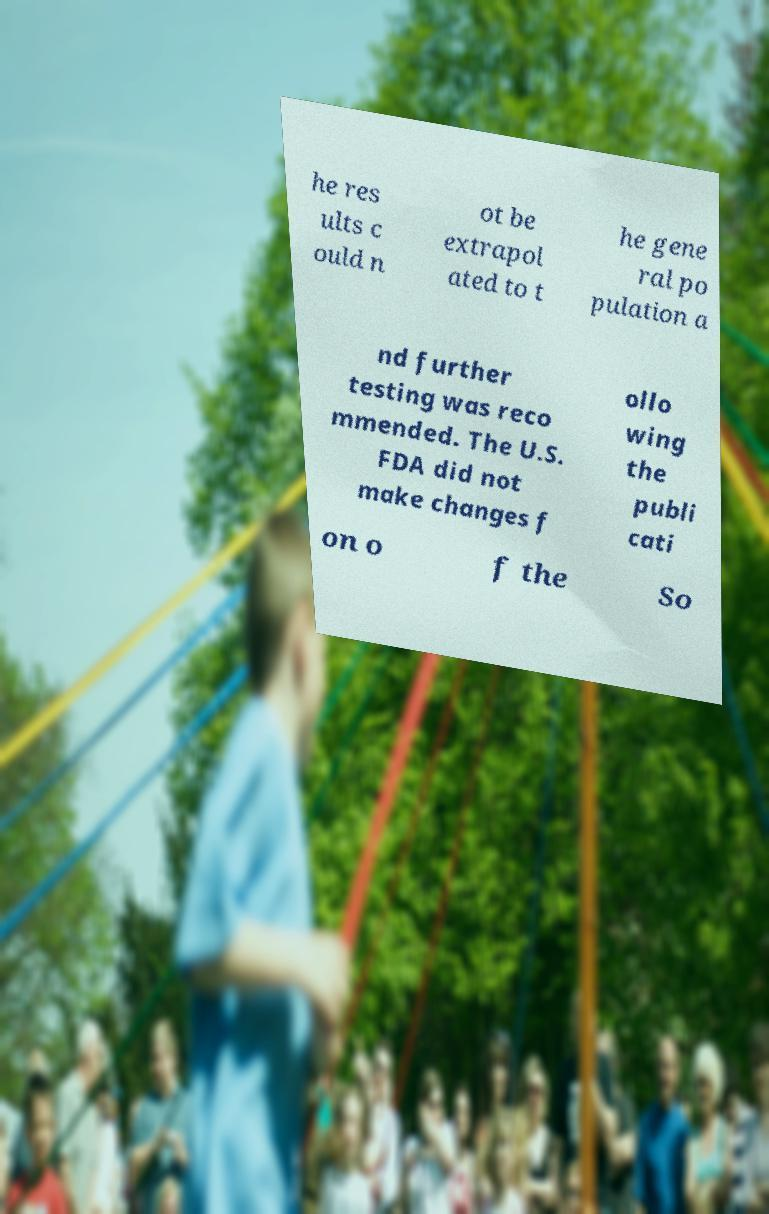Please read and relay the text visible in this image. What does it say? he res ults c ould n ot be extrapol ated to t he gene ral po pulation a nd further testing was reco mmended. The U.S. FDA did not make changes f ollo wing the publi cati on o f the So 